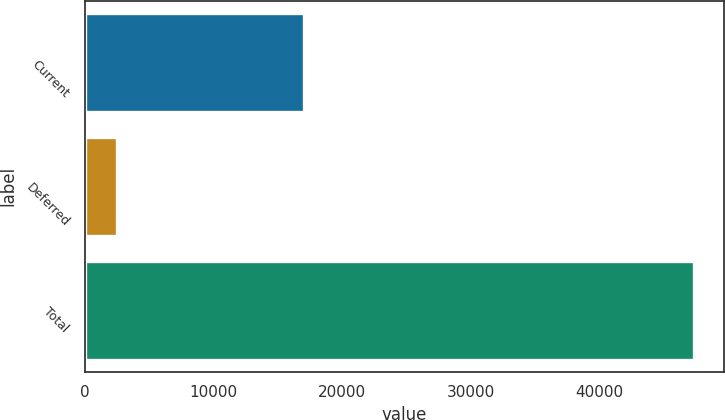<chart> <loc_0><loc_0><loc_500><loc_500><bar_chart><fcel>Current<fcel>Deferred<fcel>Total<nl><fcel>17066<fcel>2486<fcel>47309<nl></chart> 